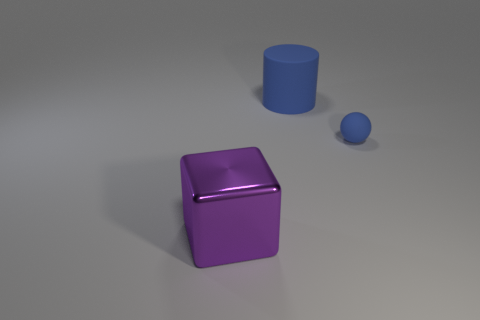Is there any other thing that has the same size as the blue rubber sphere?
Offer a very short reply. No. There is a small thing; is it the same color as the large thing to the right of the purple metallic cube?
Make the answer very short. Yes. There is a large thing that is behind the big metallic block; does it have the same color as the matte object that is on the right side of the large blue rubber object?
Make the answer very short. Yes. What size is the object that is the same color as the cylinder?
Offer a terse response. Small. What number of large objects are either green matte cylinders or blue rubber things?
Ensure brevity in your answer.  1. How many purple things are there?
Make the answer very short. 1. Are there the same number of large things that are behind the large rubber cylinder and large metal cubes to the right of the tiny thing?
Provide a short and direct response. Yes. Are there any blue balls right of the large purple metallic object?
Your answer should be compact. Yes. What color is the object that is left of the blue matte cylinder?
Your response must be concise. Purple. The thing to the right of the large object behind the cube is made of what material?
Provide a succinct answer. Rubber. 